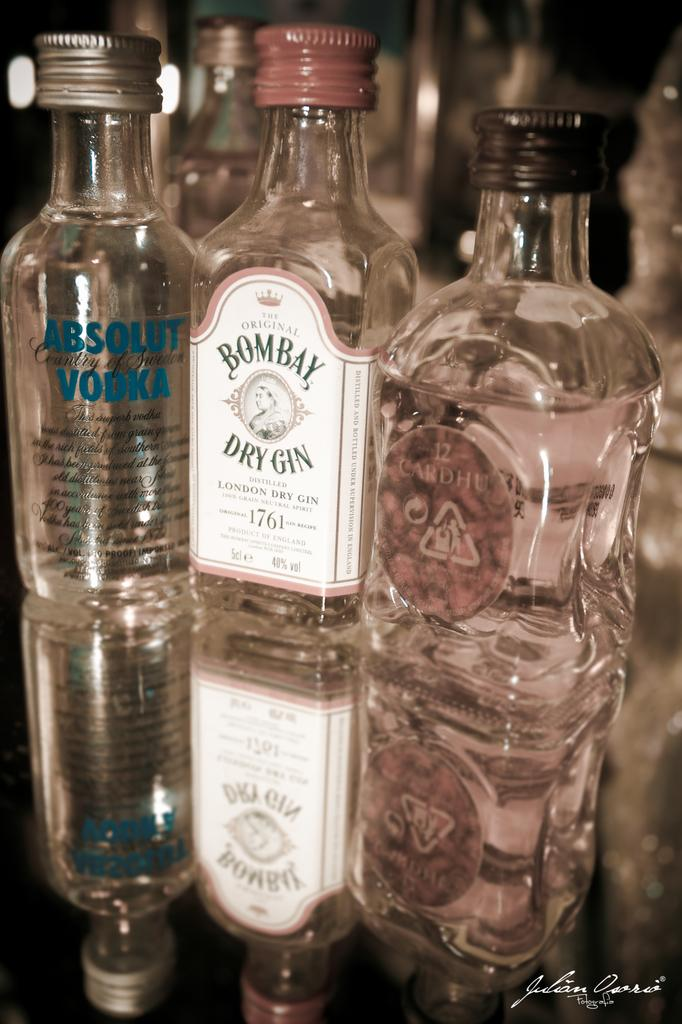<image>
Offer a succinct explanation of the picture presented. Dry gin, vodka and more sit on this glass table 